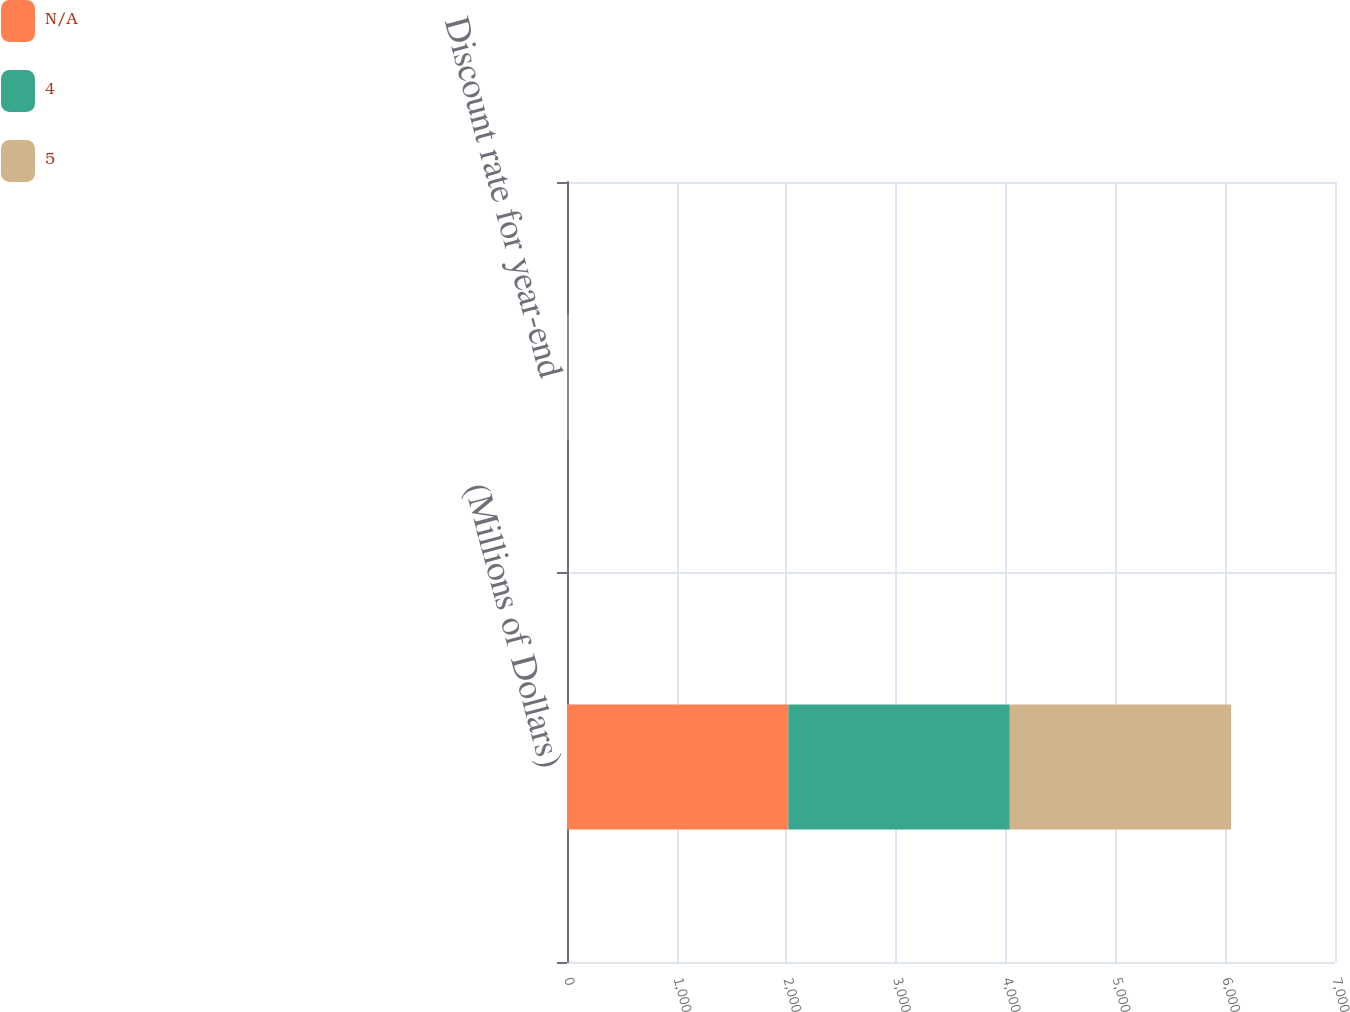<chart> <loc_0><loc_0><loc_500><loc_500><stacked_bar_chart><ecel><fcel>(Millions of Dollars)<fcel>Discount rate for year-end<nl><fcel>nan<fcel>2018<fcel>4.31<nl><fcel>4<fcel>2018<fcel>4.32<nl><fcel>5<fcel>2017<fcel>3.62<nl></chart> 